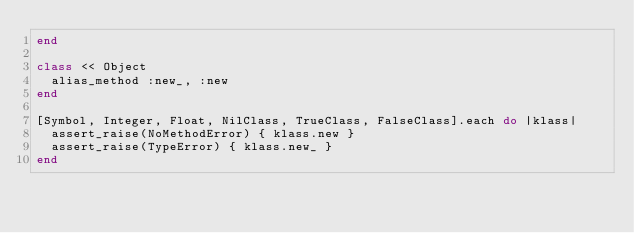Convert code to text. <code><loc_0><loc_0><loc_500><loc_500><_Ruby_>end

class << Object
  alias_method :new_, :new
end

[Symbol, Integer, Float, NilClass, TrueClass, FalseClass].each do |klass|
  assert_raise(NoMethodError) { klass.new }
  assert_raise(TypeError) { klass.new_ }
end
</code> 